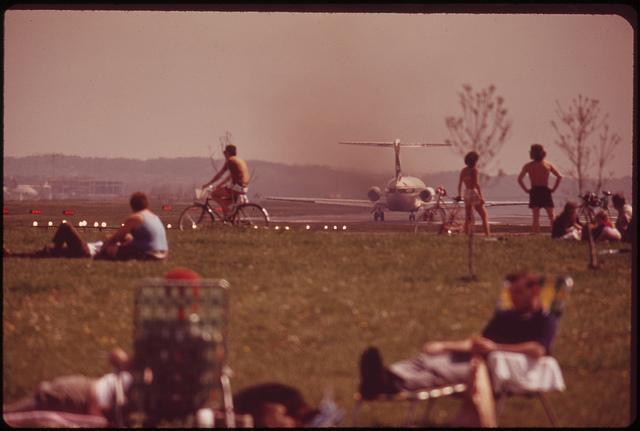How many chairs can be seen?
Give a very brief answer. 2. How many people are there?
Give a very brief answer. 4. 